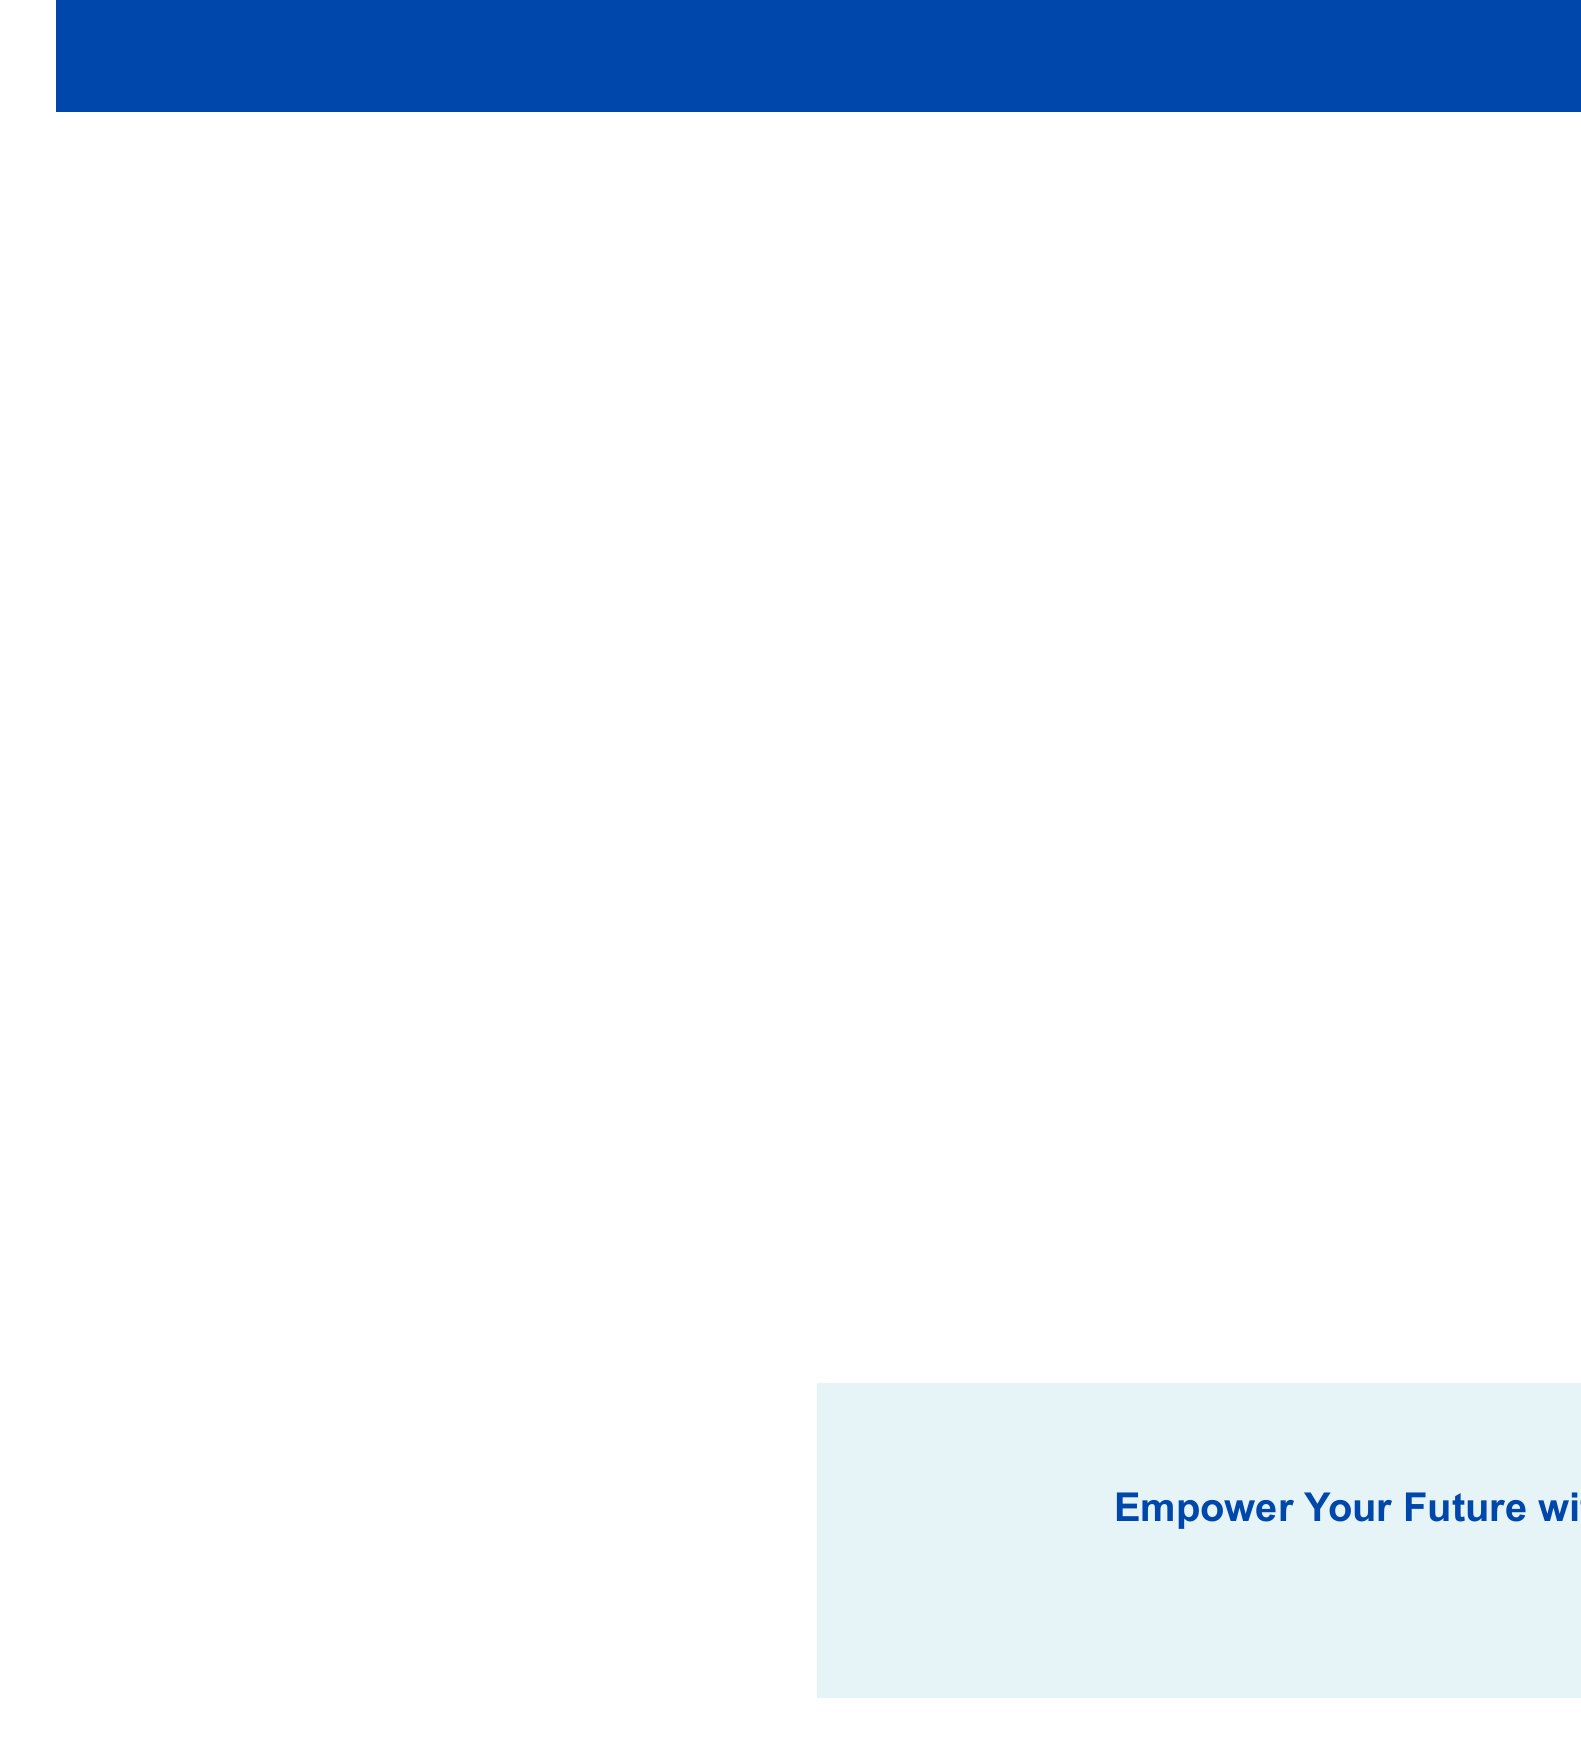What is the title of the continuing education program? The title is mentioned at the top of the document underlined by a blue box.
Answer: Hokkaido Science University Alumni Continuing Education Program Who is the instructor for the Advanced Data Analytics course? The instructor's name is listed under the featured courses section in relation to the course title.
Answer: Dr. Akira Tanaka How long is the course on Climate Change? The duration is specified next to the course title in the featured courses list.
Answer: 8 weeks What date is the Networking Skills workshop scheduled? The date for the workshop is shown next to its title in the workshops section.
Answer: July 15, 2023 What percentage discount do alumni receive on courses? The discount percentage is indicated in the alumni benefits section.
Answer: 10% Which two course categories are listed in the document? The categories are listed in the course categories section, providing a summary of the offerings.
Answer: Science and Technology, Business and Management Where can alumni register for courses? The registration information section provides the contact details for alumni to register.
Answer: www.hsu-alumni-education.ac.jp What city will the Innovation in Hokkaido's Agriculture Technology workshop take place? The location is given alongside the workshop title in the workshops section.
Answer: Obihiro University 